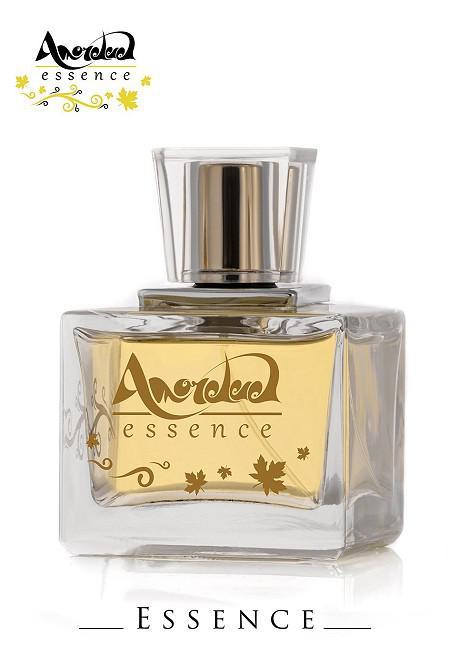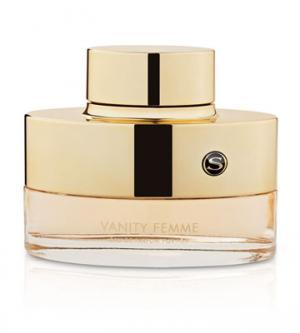The first image is the image on the left, the second image is the image on the right. Assess this claim about the two images: "one of the images contains a cylinder.". Correct or not? Answer yes or no. No. 